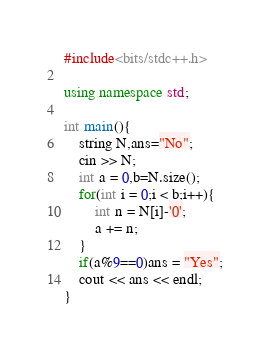Convert code to text. <code><loc_0><loc_0><loc_500><loc_500><_C++_>#include<bits/stdc++.h>

using namespace std;

int main(){
    string N,ans="No";
    cin >> N;
    int a = 0,b=N.size();
    for(int i = 0;i < b;i++){
        int n = N[i]-'0';
        a += n;
    }
    if(a%9==0)ans = "Yes";
    cout << ans << endl;
}</code> 